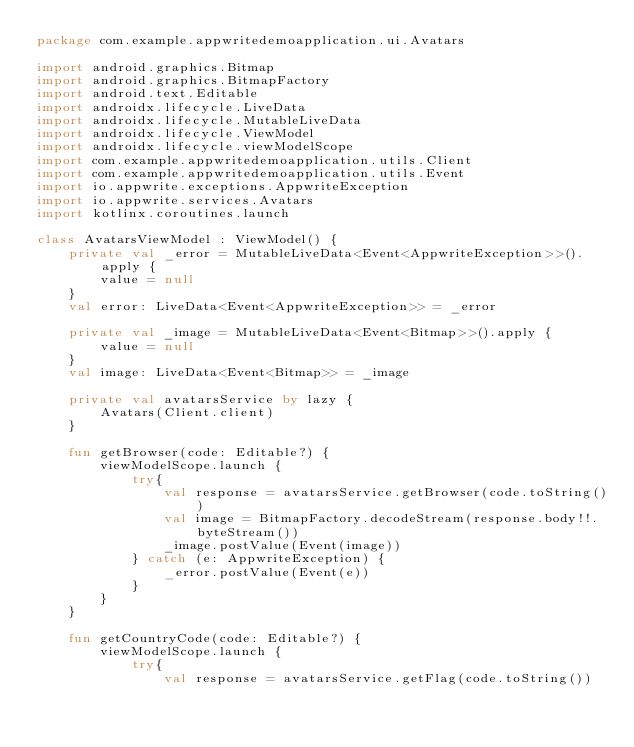Convert code to text. <code><loc_0><loc_0><loc_500><loc_500><_Kotlin_>package com.example.appwritedemoapplication.ui.Avatars

import android.graphics.Bitmap
import android.graphics.BitmapFactory
import android.text.Editable
import androidx.lifecycle.LiveData
import androidx.lifecycle.MutableLiveData
import androidx.lifecycle.ViewModel
import androidx.lifecycle.viewModelScope
import com.example.appwritedemoapplication.utils.Client
import com.example.appwritedemoapplication.utils.Event
import io.appwrite.exceptions.AppwriteException
import io.appwrite.services.Avatars
import kotlinx.coroutines.launch

class AvatarsViewModel : ViewModel() {
    private val _error = MutableLiveData<Event<AppwriteException>>().apply {
        value = null
    }
    val error: LiveData<Event<AppwriteException>> = _error

    private val _image = MutableLiveData<Event<Bitmap>>().apply {
        value = null
    }
    val image: LiveData<Event<Bitmap>> = _image

    private val avatarsService by lazy {
        Avatars(Client.client)
    }

    fun getBrowser(code: Editable?) {
        viewModelScope.launch {
            try{
                val response = avatarsService.getBrowser(code.toString())
                val image = BitmapFactory.decodeStream(response.body!!.byteStream())
                _image.postValue(Event(image))
            } catch (e: AppwriteException) {
                _error.postValue(Event(e))
            }
        }
    }

    fun getCountryCode(code: Editable?) {
        viewModelScope.launch {
            try{
                val response = avatarsService.getFlag(code.toString())</code> 